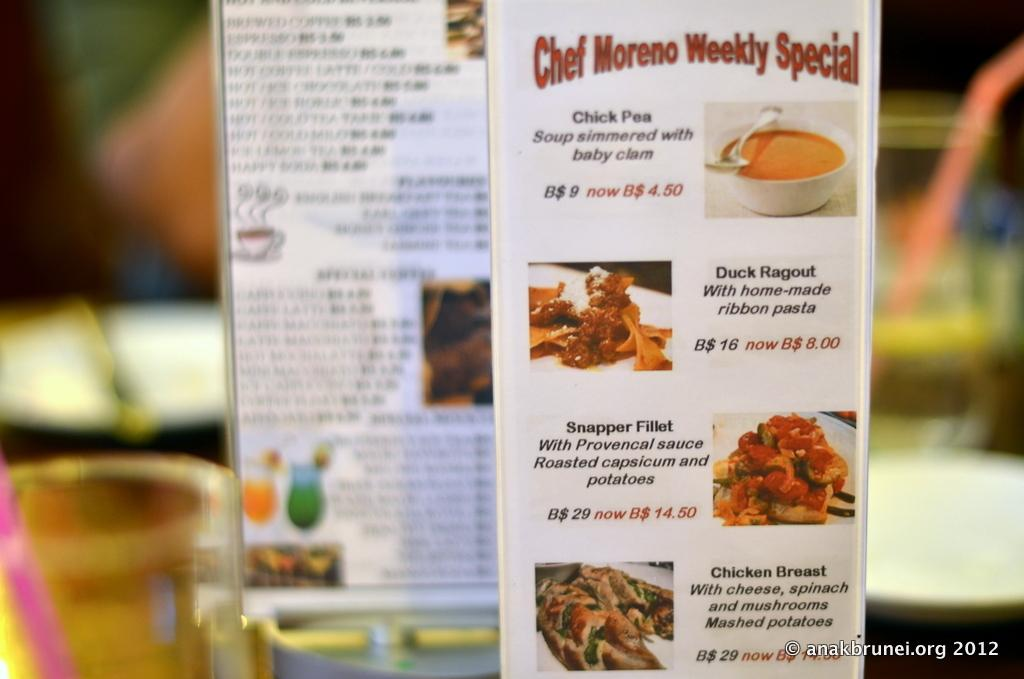<image>
Summarize the visual content of the image. a menu that is titled 'chef moreno weekly special' in red 